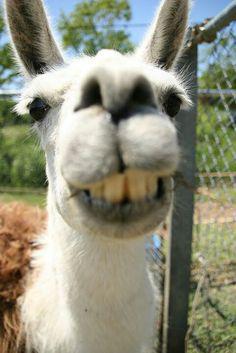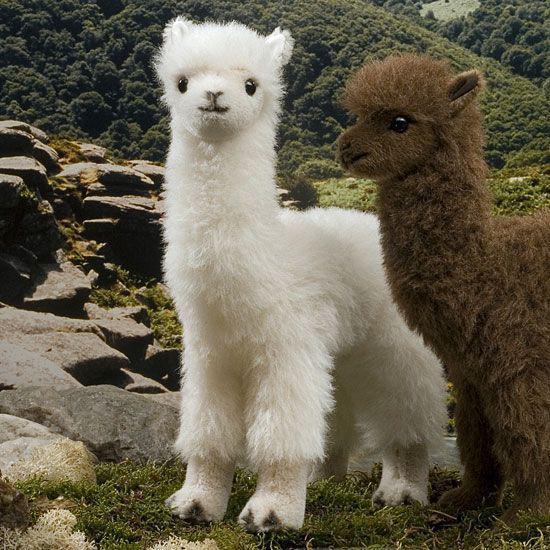The first image is the image on the left, the second image is the image on the right. Considering the images on both sides, is "The left and right image contains three llamas." valid? Answer yes or no. Yes. 